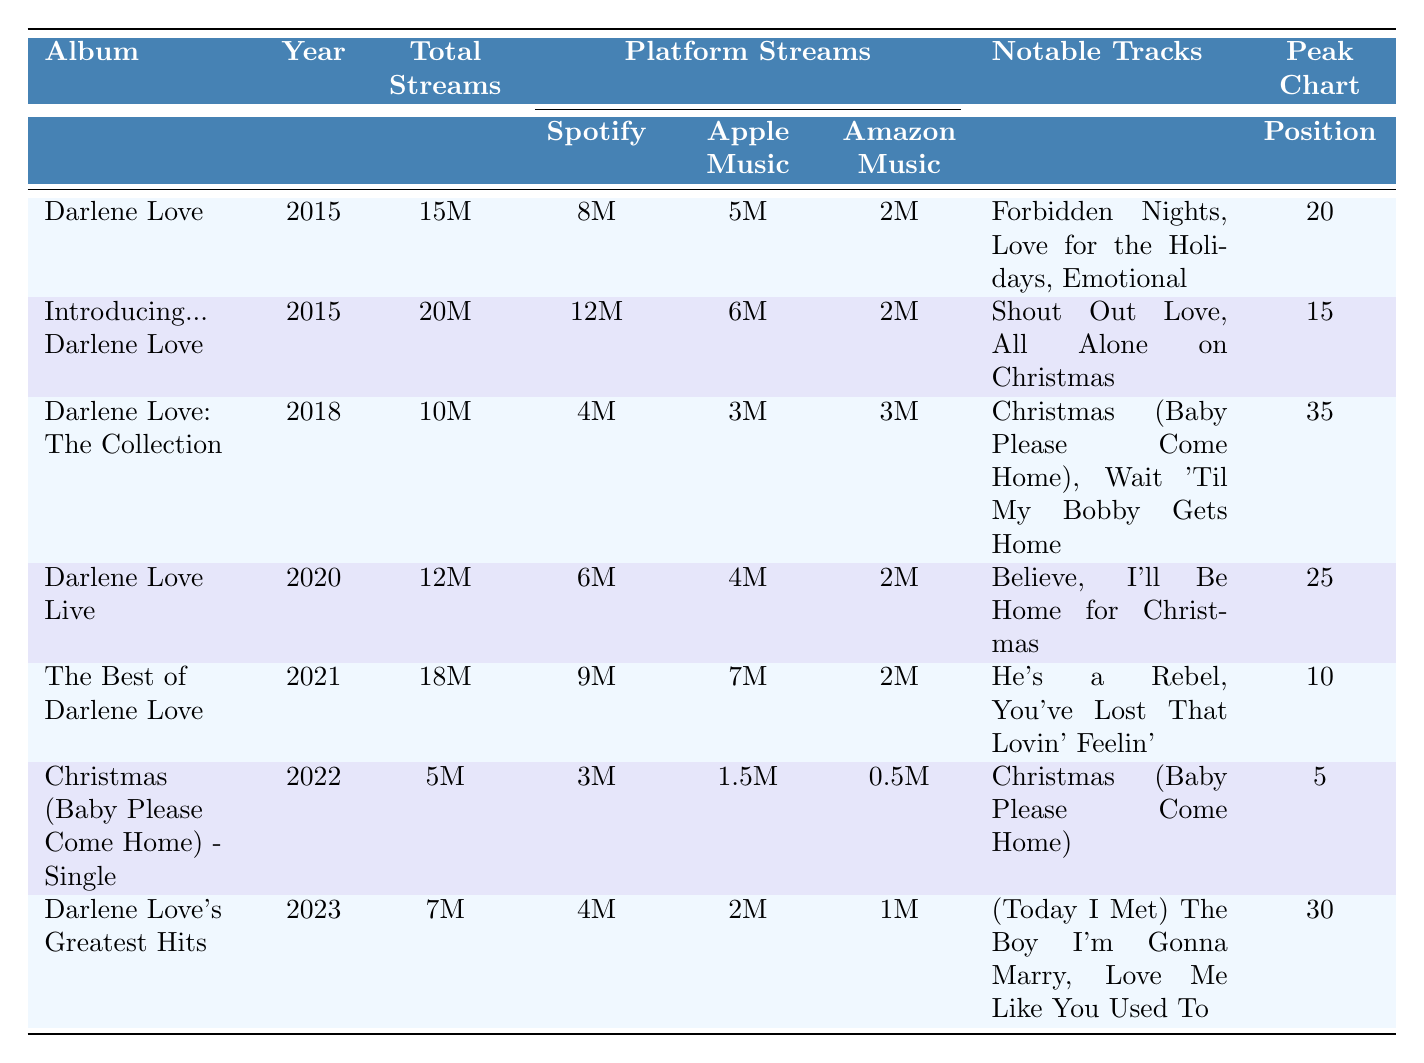What is the total number of streams for "The Best of Darlene Love"? The table lists "The Best of Darlene Love" under the album column and shows that it has a total of 18 million streams.
Answer: 18 million Which album has the highest total streams? By comparing the total streams across all albums, "Introducing... Darlene Love" has 20 million, which is the highest compared to others listed.
Answer: Introducing... Darlene Love What are the notable tracks in "Darlene Love Live"? Looking at the row for "Darlene Love Live," the notable tracks listed are "Believe" and "I’ll Be Home for Christmas."
Answer: Believe, I’ll Be Home for Christmas How many total streams did "Christmas (Baby Please Come Home) - Single" receive? The table directly states that "Christmas (Baby Please Come Home) - Single" received a total of 5 million streams.
Answer: 5 million What is the peak chart position of "Darlene Love: The Collection"? The table shows that "Darlene Love: The Collection" has a peak chart position of 35 as indicated in its row.
Answer: 35 What is the difference in total streams between "Darlene Love" and "Darlene Love Live"? "Darlene Love" has 15 million streams, and "Darlene Love Live" has 12 million. The difference is (15 - 12) = 3 million streams.
Answer: 3 million Which album was released first, "Christmas (Baby Please Come Home) - Single" or "Darlene Love's Greatest Hits"? Checking their release years in the table, "Christmas (Baby Please Come Home) - Single" was released in 2022 while "Darlene Love's Greatest Hits" was released in 2023, thus it was released first.
Answer: Christmas (Baby Please Come Home) - Single Is "He’s a Rebel" a notable track in the album "Darlene Love: The Collection"? Looking in the notable tracks of "Darlene Love: The Collection", it lists "Christmas (Baby Please Come Home)" and "Wait 'Til My Bobby Gets Home", so "He’s a Rebel" is not associated with that album.
Answer: No Calculate the average total streams of all albums listed from 2015 to 2023. The total streams are as follows: 15M, 20M, 10M, 12M, 18M, 5M, 7M. Summing them gives a total of 87 million. There are 7 albums, so the average is 87/7 = approximately 12.43 million.
Answer: Approximately 12.43 million Which streaming platform received the least streams for "Darlene Love's Greatest Hits"? According to the table, "Darlene Love's Greatest Hits" has 4 million on Spotify, 2 million on Apple Music, and 1 million on Amazon Music. The least is 1 million from Amazon Music.
Answer: Amazon Music 